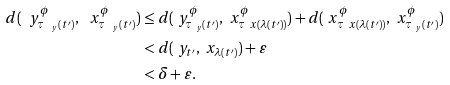<formula> <loc_0><loc_0><loc_500><loc_500>d ( \ y ^ { \phi } _ { \tau _ { \ y } ( t ^ { \prime } ) } , \ x ^ { \phi } _ { \tau _ { \ y } ( t ^ { \prime } ) } ) & \leq d ( \ y ^ { \phi } _ { \tau _ { \ y } ( t ^ { \prime } ) } , \ x ^ { \phi } _ { \tau _ { \ } x ( \lambda ( t ^ { \prime } ) ) } ) + d ( \ x ^ { \phi } _ { \tau _ { \ } x ( \lambda ( t ^ { \prime } ) ) } , \ x ^ { \phi } _ { \tau _ { \ y } ( t ^ { \prime } ) } ) \\ & < d ( \ y _ { t ^ { \prime } } , \ x _ { \lambda ( t ^ { \prime } ) } ) + \varepsilon \\ & < \delta + \varepsilon .</formula> 